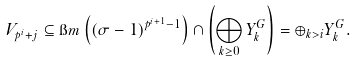Convert formula to latex. <formula><loc_0><loc_0><loc_500><loc_500>V _ { p ^ { i } + j } \subseteq \i m \left ( ( \sigma - 1 ) ^ { p ^ { i + 1 } - 1 } \right ) \cap \left ( \bigoplus _ { k \geq 0 } Y _ { k } ^ { G } \right ) = \oplus _ { k > i } Y _ { k } ^ { G } .</formula> 